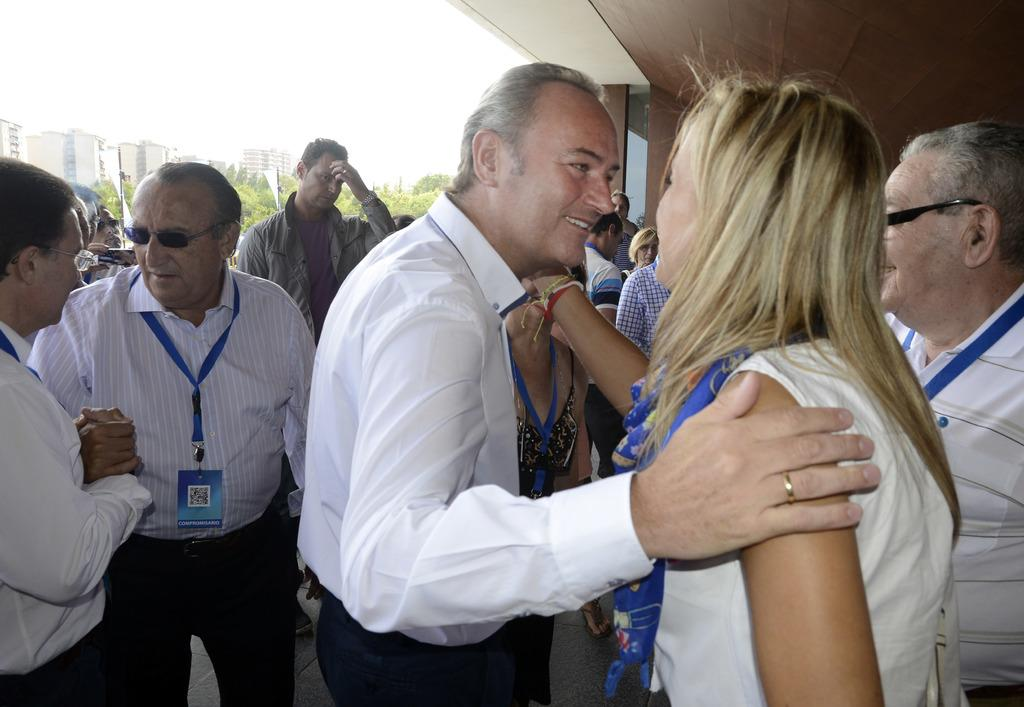How many people are in the image? There is a group of people in the image. What are the people in the image doing? The people are standing. What can be seen in the background of the image? There are trees and a building visible in the background of the image. What is visible at the top of the image? The sky is visible at the top of the image. What architectural feature is visible in the image? There is a roof visible in the image. What type of bucket is being used to adjust the height of the trees in the image? There is no bucket or adjustment of tree height visible in the image. 